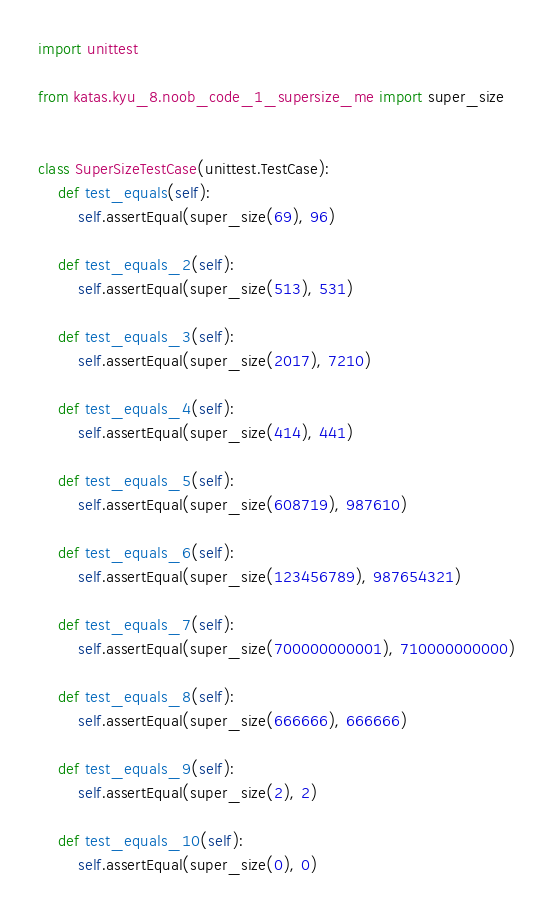<code> <loc_0><loc_0><loc_500><loc_500><_Python_>import unittest

from katas.kyu_8.noob_code_1_supersize_me import super_size


class SuperSizeTestCase(unittest.TestCase):
    def test_equals(self):
        self.assertEqual(super_size(69), 96)

    def test_equals_2(self):
        self.assertEqual(super_size(513), 531)

    def test_equals_3(self):
        self.assertEqual(super_size(2017), 7210)

    def test_equals_4(self):
        self.assertEqual(super_size(414), 441)

    def test_equals_5(self):
        self.assertEqual(super_size(608719), 987610)

    def test_equals_6(self):
        self.assertEqual(super_size(123456789), 987654321)

    def test_equals_7(self):
        self.assertEqual(super_size(700000000001), 710000000000)

    def test_equals_8(self):
        self.assertEqual(super_size(666666), 666666)

    def test_equals_9(self):
        self.assertEqual(super_size(2), 2)

    def test_equals_10(self):
        self.assertEqual(super_size(0), 0)
</code> 